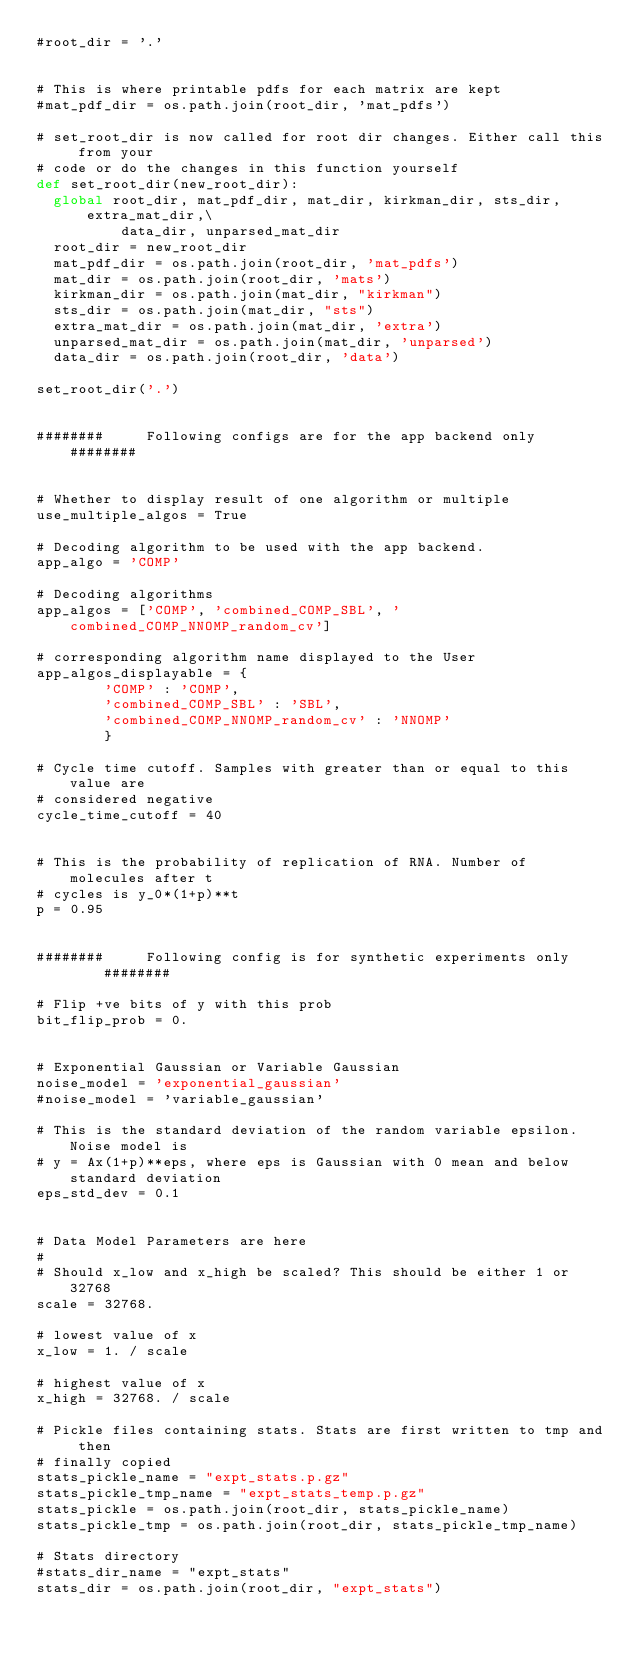Convert code to text. <code><loc_0><loc_0><loc_500><loc_500><_Python_>#root_dir = '.'


# This is where printable pdfs for each matrix are kept
#mat_pdf_dir = os.path.join(root_dir, 'mat_pdfs')

# set_root_dir is now called for root dir changes. Either call this from your
# code or do the changes in this function yourself
def set_root_dir(new_root_dir):
  global root_dir, mat_pdf_dir, mat_dir, kirkman_dir, sts_dir, extra_mat_dir,\
          data_dir, unparsed_mat_dir
  root_dir = new_root_dir
  mat_pdf_dir = os.path.join(root_dir, 'mat_pdfs')
  mat_dir = os.path.join(root_dir, 'mats')
  kirkman_dir = os.path.join(mat_dir, "kirkman")
  sts_dir = os.path.join(mat_dir, "sts")
  extra_mat_dir = os.path.join(mat_dir, 'extra')
  unparsed_mat_dir = os.path.join(mat_dir, 'unparsed')
  data_dir = os.path.join(root_dir, 'data')

set_root_dir('.')


########     Following configs are for the app backend only     ########


# Whether to display result of one algorithm or multiple
use_multiple_algos = True

# Decoding algorithm to be used with the app backend.
app_algo = 'COMP'

# Decoding algorithms
app_algos = ['COMP', 'combined_COMP_SBL', 'combined_COMP_NNOMP_random_cv']

# corresponding algorithm name displayed to the User
app_algos_displayable = {
        'COMP' : 'COMP',
        'combined_COMP_SBL' : 'SBL',
        'combined_COMP_NNOMP_random_cv' : 'NNOMP'
        }

# Cycle time cutoff. Samples with greater than or equal to this value are
# considered negative
cycle_time_cutoff = 40


# This is the probability of replication of RNA. Number of molecules after t
# cycles is y_0*(1+p)**t
p = 0.95


########     Following config is for synthetic experiments only     ########

# Flip +ve bits of y with this prob
bit_flip_prob = 0.


# Exponential Gaussian or Variable Gaussian
noise_model = 'exponential_gaussian'
#noise_model = 'variable_gaussian'

# This is the standard deviation of the random variable epsilon. Noise model is
# y = Ax(1+p)**eps, where eps is Gaussian with 0 mean and below standard deviation
eps_std_dev = 0.1


# Data Model Parameters are here
#
# Should x_low and x_high be scaled? This should be either 1 or 32768
scale = 32768.

# lowest value of x
x_low = 1. / scale

# highest value of x
x_high = 32768. / scale

# Pickle files containing stats. Stats are first written to tmp and then
# finally copied
stats_pickle_name = "expt_stats.p.gz"
stats_pickle_tmp_name = "expt_stats_temp.p.gz"
stats_pickle = os.path.join(root_dir, stats_pickle_name) 
stats_pickle_tmp = os.path.join(root_dir, stats_pickle_tmp_name)

# Stats directory
#stats_dir_name = "expt_stats"
stats_dir = os.path.join(root_dir, "expt_stats")

</code> 